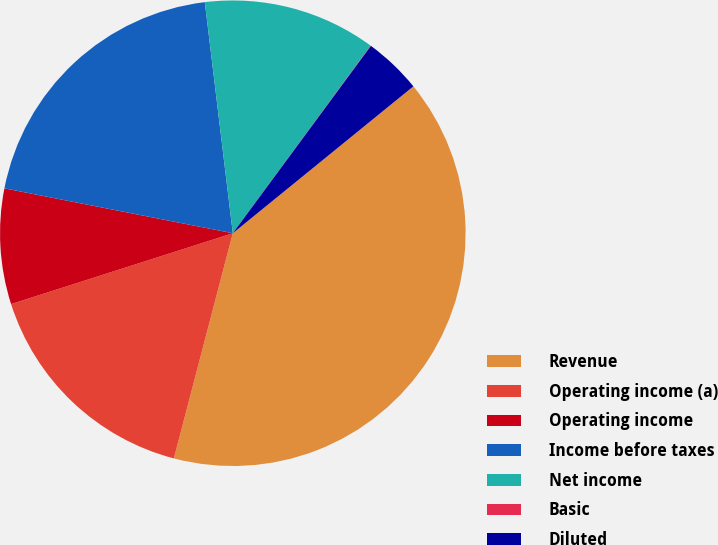Convert chart to OTSL. <chart><loc_0><loc_0><loc_500><loc_500><pie_chart><fcel>Revenue<fcel>Operating income (a)<fcel>Operating income<fcel>Income before taxes<fcel>Net income<fcel>Basic<fcel>Diluted<nl><fcel>39.94%<fcel>16.0%<fcel>8.01%<fcel>19.99%<fcel>12.0%<fcel>0.03%<fcel>4.02%<nl></chart> 